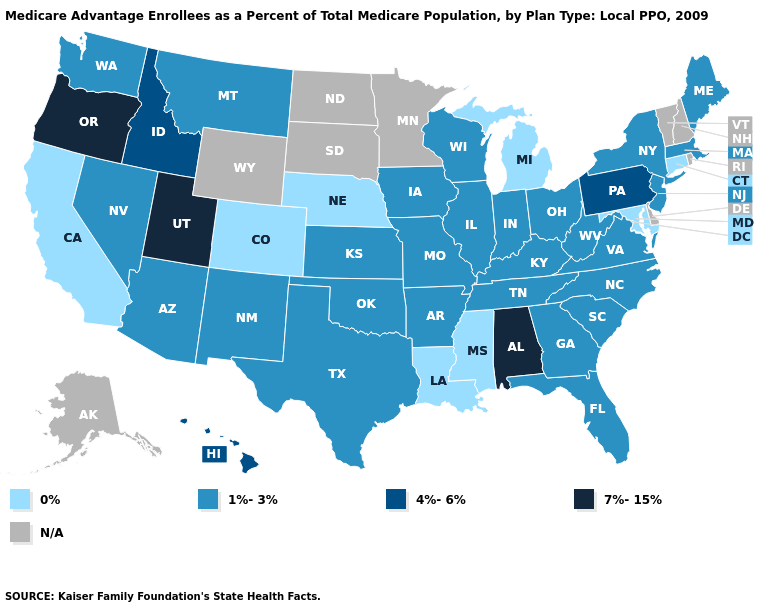Name the states that have a value in the range 0%?
Write a very short answer. California, Colorado, Connecticut, Louisiana, Maryland, Michigan, Mississippi, Nebraska. Does Connecticut have the highest value in the Northeast?
Keep it brief. No. Which states have the lowest value in the Northeast?
Write a very short answer. Connecticut. Does the map have missing data?
Answer briefly. Yes. What is the value of Connecticut?
Quick response, please. 0%. What is the value of West Virginia?
Be succinct. 1%-3%. Which states have the highest value in the USA?
Answer briefly. Alabama, Oregon, Utah. What is the value of Colorado?
Be succinct. 0%. Name the states that have a value in the range 4%-6%?
Quick response, please. Hawaii, Idaho, Pennsylvania. What is the value of New Jersey?
Write a very short answer. 1%-3%. Which states have the highest value in the USA?
Give a very brief answer. Alabama, Oregon, Utah. Which states have the lowest value in the MidWest?
Quick response, please. Michigan, Nebraska. How many symbols are there in the legend?
Answer briefly. 5. What is the lowest value in the MidWest?
Concise answer only. 0%. 